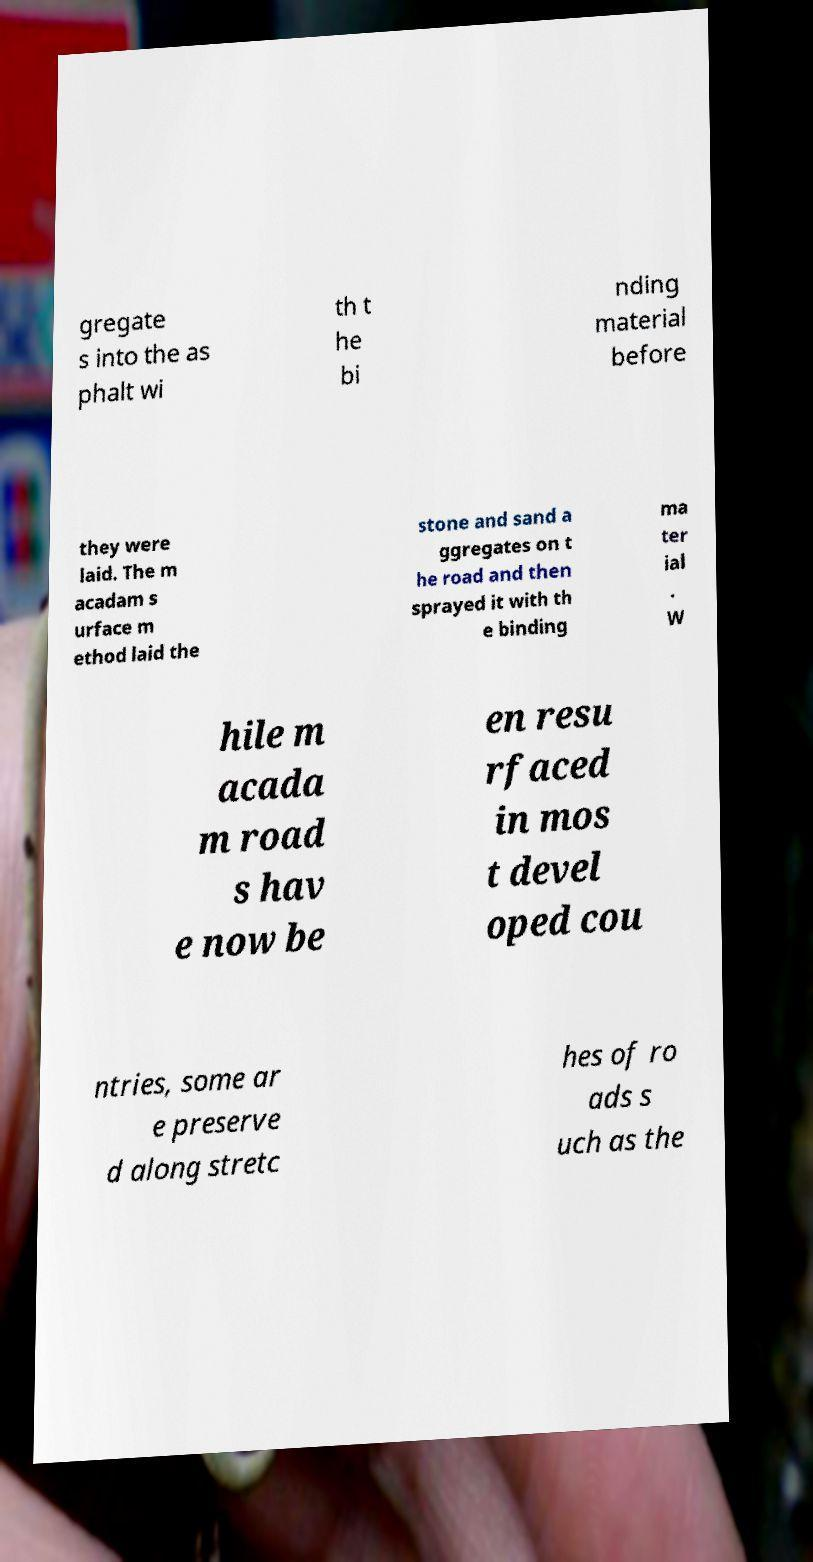Can you read and provide the text displayed in the image?This photo seems to have some interesting text. Can you extract and type it out for me? gregate s into the as phalt wi th t he bi nding material before they were laid. The m acadam s urface m ethod laid the stone and sand a ggregates on t he road and then sprayed it with th e binding ma ter ial . W hile m acada m road s hav e now be en resu rfaced in mos t devel oped cou ntries, some ar e preserve d along stretc hes of ro ads s uch as the 